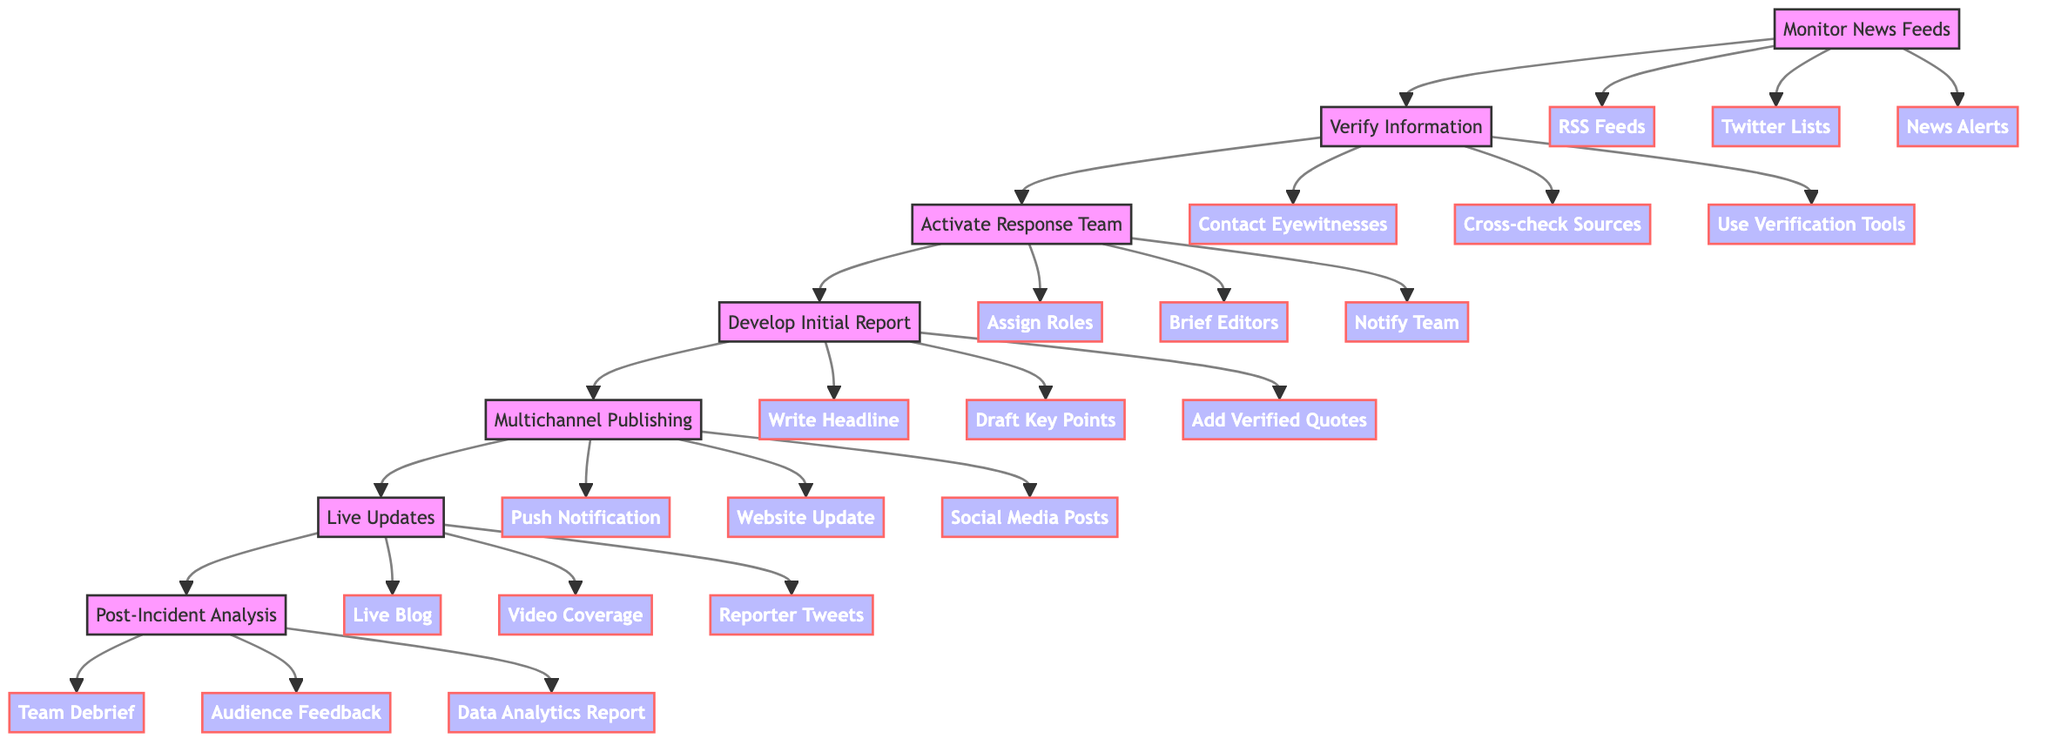What's the first action in the flowchart? The flowchart starts with the node "Monitor News Feeds," which is the first step in the process that initiates the breaking news response plan.
Answer: Monitor News Feeds How many major actions are there in the flowchart? The flowchart consists of a total of seven major actions, listed sequentially from "Monitor News Feeds" to "Post-Incident Analysis."
Answer: Seven Which action follows "Verify Information"? The diagram indicates that "Activate Response Team" directly follows "Verify Information," marking the next step after verification is complete.
Answer: Activate Response Team What is the last action in the flowchart? The flowchart concludes with "Post-Incident Analysis," which is the final step in evaluating the news coverage after the event has transpired.
Answer: Post-Incident Analysis How are eyewitnesses contacted for verification? Eyewitnesses are contacted in the second action, "Verify Information," specifically utilizing the action linked to "Contact Eyewitnesses" as part of the verification process.
Answer: Contact Eyewitnesses What type of content is developed after activating the response team? After activating the response team, the action "Develop Initial Report" is performed to prepare a draft of the breaking news, which involves creating an initial write-up.
Answer: Develop Initial Report Name one of the multichannel publishing actions. The flowchart presents "Push Notification," "Website Update," and "Social Media Posts" as the actions included in the "Multichannel Publishing" phase, any of which can be a suitable answer.
Answer: Push Notification Which action provides ongoing information? The "Live Updates" action offers ongoing information by continuing to provide real-time updates related to the breaking news story as it develops.
Answer: Live Updates What occurs after live updates are provided? Following "Live Updates," the next step outlined in the flowchart is the "Post-Incident Analysis," which reviews the effectiveness and scope of the coverage after the incident ends.
Answer: Post-Incident Analysis 